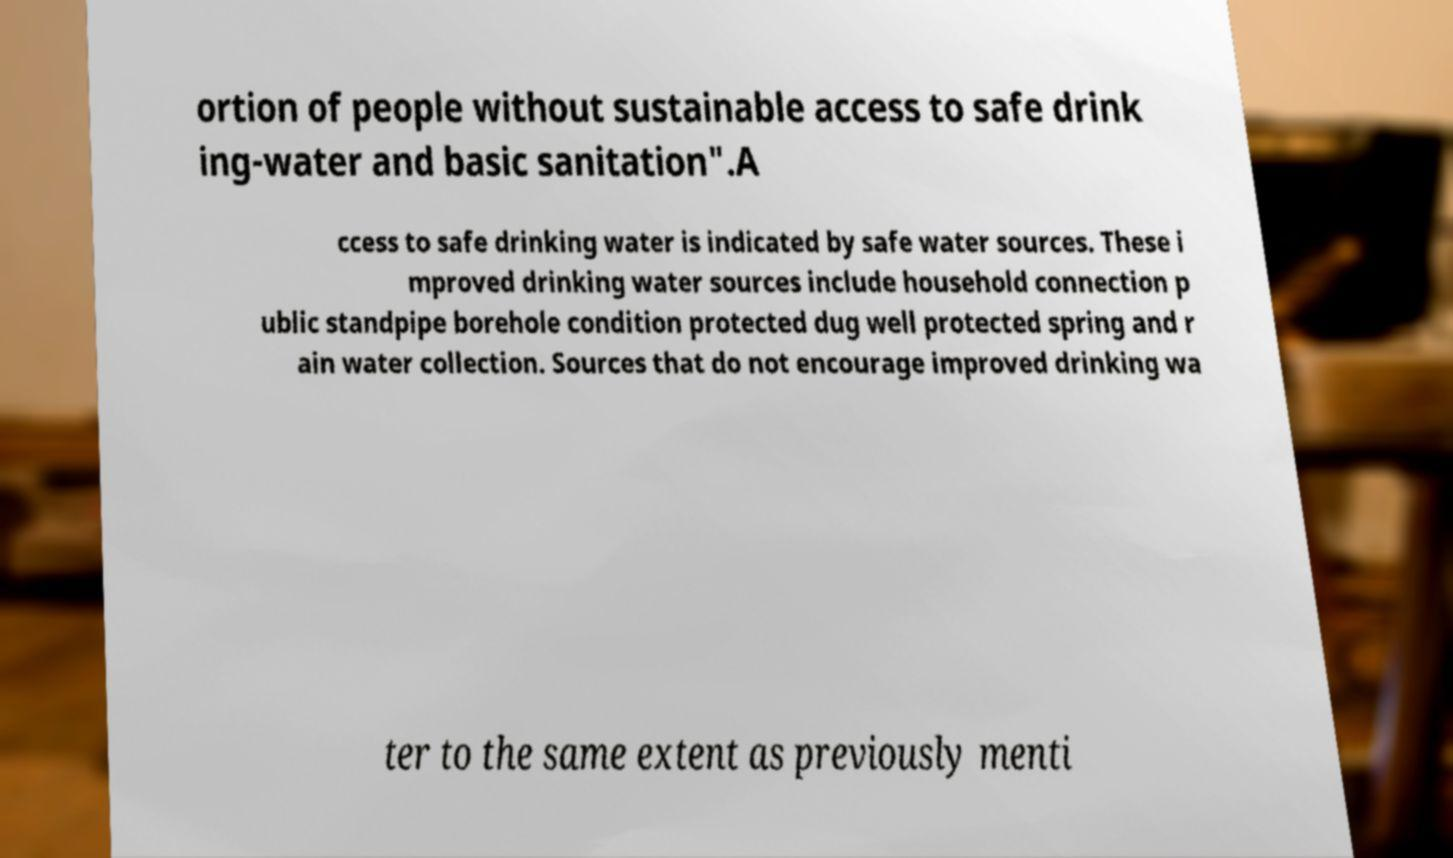Can you read and provide the text displayed in the image?This photo seems to have some interesting text. Can you extract and type it out for me? ortion of people without sustainable access to safe drink ing-water and basic sanitation".A ccess to safe drinking water is indicated by safe water sources. These i mproved drinking water sources include household connection p ublic standpipe borehole condition protected dug well protected spring and r ain water collection. Sources that do not encourage improved drinking wa ter to the same extent as previously menti 